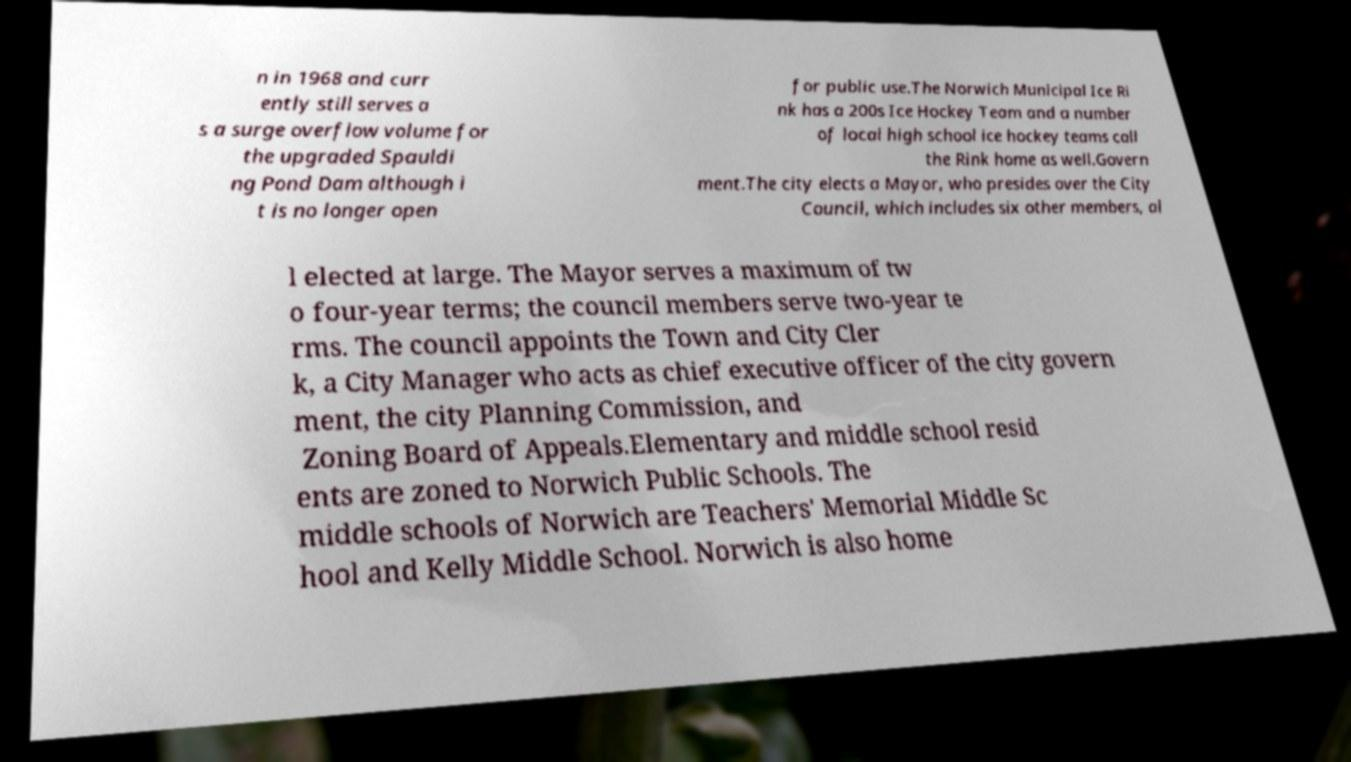Could you extract and type out the text from this image? n in 1968 and curr ently still serves a s a surge overflow volume for the upgraded Spauldi ng Pond Dam although i t is no longer open for public use.The Norwich Municipal Ice Ri nk has a 200s Ice Hockey Team and a number of local high school ice hockey teams call the Rink home as well.Govern ment.The city elects a Mayor, who presides over the City Council, which includes six other members, al l elected at large. The Mayor serves a maximum of tw o four-year terms; the council members serve two-year te rms. The council appoints the Town and City Cler k, a City Manager who acts as chief executive officer of the city govern ment, the city Planning Commission, and Zoning Board of Appeals.Elementary and middle school resid ents are zoned to Norwich Public Schools. The middle schools of Norwich are Teachers' Memorial Middle Sc hool and Kelly Middle School. Norwich is also home 